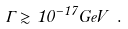Convert formula to latex. <formula><loc_0><loc_0><loc_500><loc_500>\Gamma \gtrsim 1 0 ^ { - 1 7 } G e V \ .</formula> 